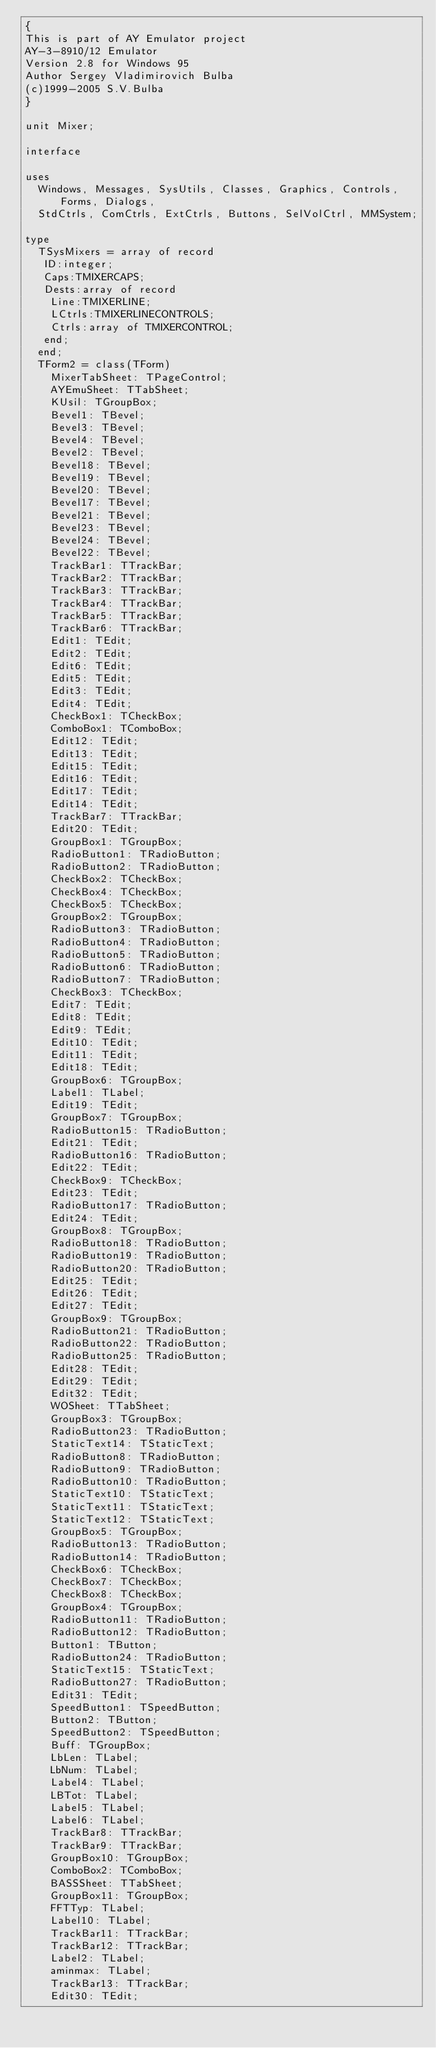<code> <loc_0><loc_0><loc_500><loc_500><_Pascal_>{
This is part of AY Emulator project
AY-3-8910/12 Emulator
Version 2.8 for Windows 95
Author Sergey Vladimirovich Bulba
(c)1999-2005 S.V.Bulba
}

unit Mixer;

interface

uses
  Windows, Messages, SysUtils, Classes, Graphics, Controls, Forms, Dialogs,
  StdCtrls, ComCtrls, ExtCtrls, Buttons, SelVolCtrl, MMSystem;

type
  TSysMixers = array of record
   ID:integer;
   Caps:TMIXERCAPS;
   Dests:array of record
    Line:TMIXERLINE;
    LCtrls:TMIXERLINECONTROLS;
    Ctrls:array of TMIXERCONTROL;
   end;
  end;
  TForm2 = class(TForm)
    MixerTabSheet: TPageControl;
    AYEmuSheet: TTabSheet;
    KUsil: TGroupBox;
    Bevel1: TBevel;
    Bevel3: TBevel;
    Bevel4: TBevel;
    Bevel2: TBevel;
    Bevel18: TBevel;
    Bevel19: TBevel;
    Bevel20: TBevel;
    Bevel17: TBevel;
    Bevel21: TBevel;
    Bevel23: TBevel;
    Bevel24: TBevel;
    Bevel22: TBevel;
    TrackBar1: TTrackBar;
    TrackBar2: TTrackBar;
    TrackBar3: TTrackBar;
    TrackBar4: TTrackBar;
    TrackBar5: TTrackBar;
    TrackBar6: TTrackBar;
    Edit1: TEdit;
    Edit2: TEdit;
    Edit6: TEdit;
    Edit5: TEdit;
    Edit3: TEdit;
    Edit4: TEdit;
    CheckBox1: TCheckBox;
    ComboBox1: TComboBox;
    Edit12: TEdit;
    Edit13: TEdit;
    Edit15: TEdit;
    Edit16: TEdit;
    Edit17: TEdit;
    Edit14: TEdit;
    TrackBar7: TTrackBar;
    Edit20: TEdit;
    GroupBox1: TGroupBox;
    RadioButton1: TRadioButton;
    RadioButton2: TRadioButton;
    CheckBox2: TCheckBox;
    CheckBox4: TCheckBox;
    CheckBox5: TCheckBox;
    GroupBox2: TGroupBox;
    RadioButton3: TRadioButton;
    RadioButton4: TRadioButton;
    RadioButton5: TRadioButton;
    RadioButton6: TRadioButton;
    RadioButton7: TRadioButton;
    CheckBox3: TCheckBox;
    Edit7: TEdit;
    Edit8: TEdit;
    Edit9: TEdit;
    Edit10: TEdit;
    Edit11: TEdit;
    Edit18: TEdit;
    GroupBox6: TGroupBox;
    Label1: TLabel;
    Edit19: TEdit;
    GroupBox7: TGroupBox;
    RadioButton15: TRadioButton;
    Edit21: TEdit;
    RadioButton16: TRadioButton;
    Edit22: TEdit;
    CheckBox9: TCheckBox;
    Edit23: TEdit;
    RadioButton17: TRadioButton;
    Edit24: TEdit;
    GroupBox8: TGroupBox;
    RadioButton18: TRadioButton;
    RadioButton19: TRadioButton;
    RadioButton20: TRadioButton;
    Edit25: TEdit;
    Edit26: TEdit;
    Edit27: TEdit;
    GroupBox9: TGroupBox;
    RadioButton21: TRadioButton;
    RadioButton22: TRadioButton;
    RadioButton25: TRadioButton;
    Edit28: TEdit;
    Edit29: TEdit;
    Edit32: TEdit;
    WOSheet: TTabSheet;
    GroupBox3: TGroupBox;
    RadioButton23: TRadioButton;
    StaticText14: TStaticText;
    RadioButton8: TRadioButton;
    RadioButton9: TRadioButton;
    RadioButton10: TRadioButton;
    StaticText10: TStaticText;
    StaticText11: TStaticText;
    StaticText12: TStaticText;
    GroupBox5: TGroupBox;
    RadioButton13: TRadioButton;
    RadioButton14: TRadioButton;
    CheckBox6: TCheckBox;
    CheckBox7: TCheckBox;
    CheckBox8: TCheckBox;
    GroupBox4: TGroupBox;
    RadioButton11: TRadioButton;
    RadioButton12: TRadioButton;
    Button1: TButton;
    RadioButton24: TRadioButton;
    StaticText15: TStaticText;
    RadioButton27: TRadioButton;
    Edit31: TEdit;
    SpeedButton1: TSpeedButton;
    Button2: TButton;
    SpeedButton2: TSpeedButton;
    Buff: TGroupBox;
    LbLen: TLabel;
    LbNum: TLabel;
    Label4: TLabel;
    LBTot: TLabel;
    Label5: TLabel;
    Label6: TLabel;
    TrackBar8: TTrackBar;
    TrackBar9: TTrackBar;
    GroupBox10: TGroupBox;
    ComboBox2: TComboBox;
    BASSSheet: TTabSheet;
    GroupBox11: TGroupBox;
    FFTTyp: TLabel;
    Label10: TLabel;
    TrackBar11: TTrackBar;
    TrackBar12: TTrackBar;
    Label2: TLabel;
    aminmax: TLabel;
    TrackBar13: TTrackBar;
    Edit30: TEdit;</code> 